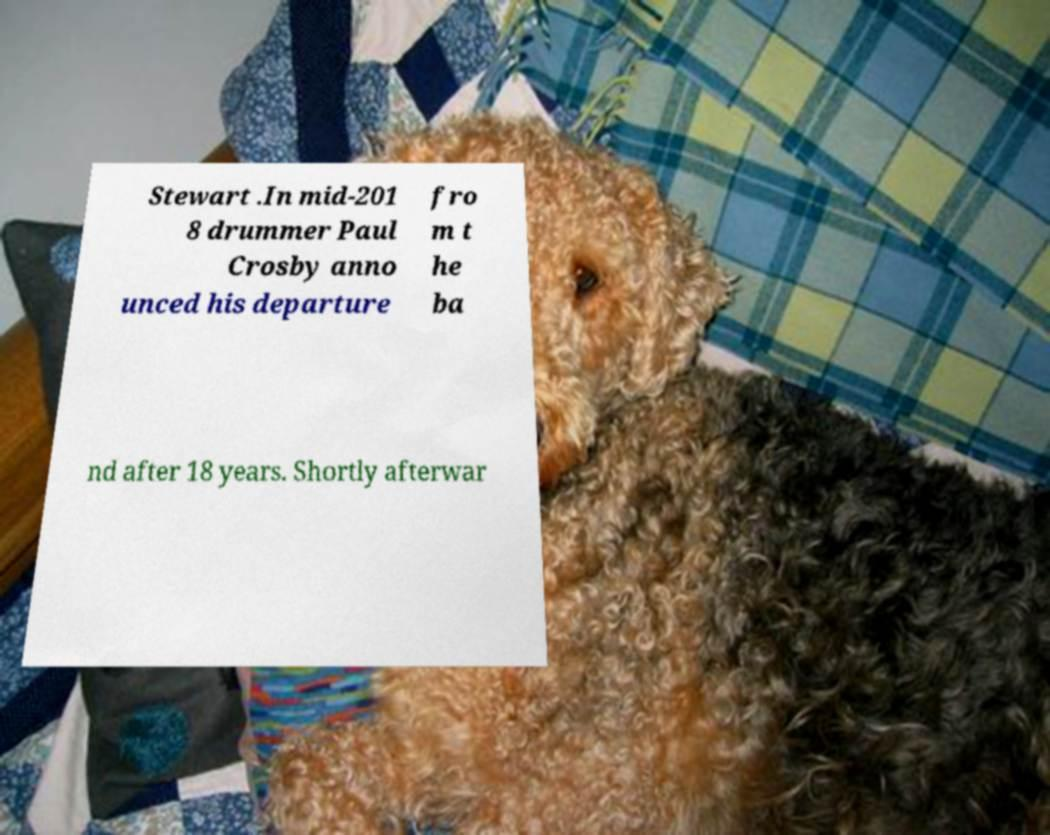There's text embedded in this image that I need extracted. Can you transcribe it verbatim? Stewart .In mid-201 8 drummer Paul Crosby anno unced his departure fro m t he ba nd after 18 years. Shortly afterwar 